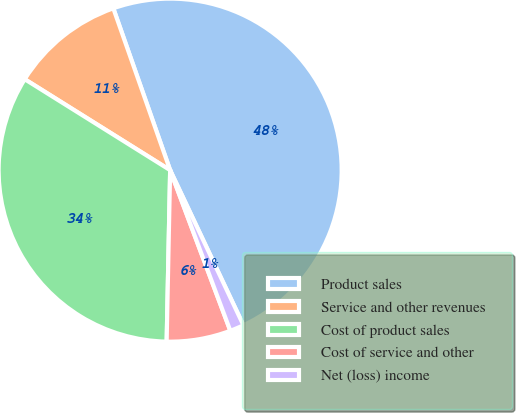Convert chart to OTSL. <chart><loc_0><loc_0><loc_500><loc_500><pie_chart><fcel>Product sales<fcel>Service and other revenues<fcel>Cost of product sales<fcel>Cost of service and other<fcel>Net (loss) income<nl><fcel>48.35%<fcel>10.73%<fcel>33.57%<fcel>6.03%<fcel>1.32%<nl></chart> 